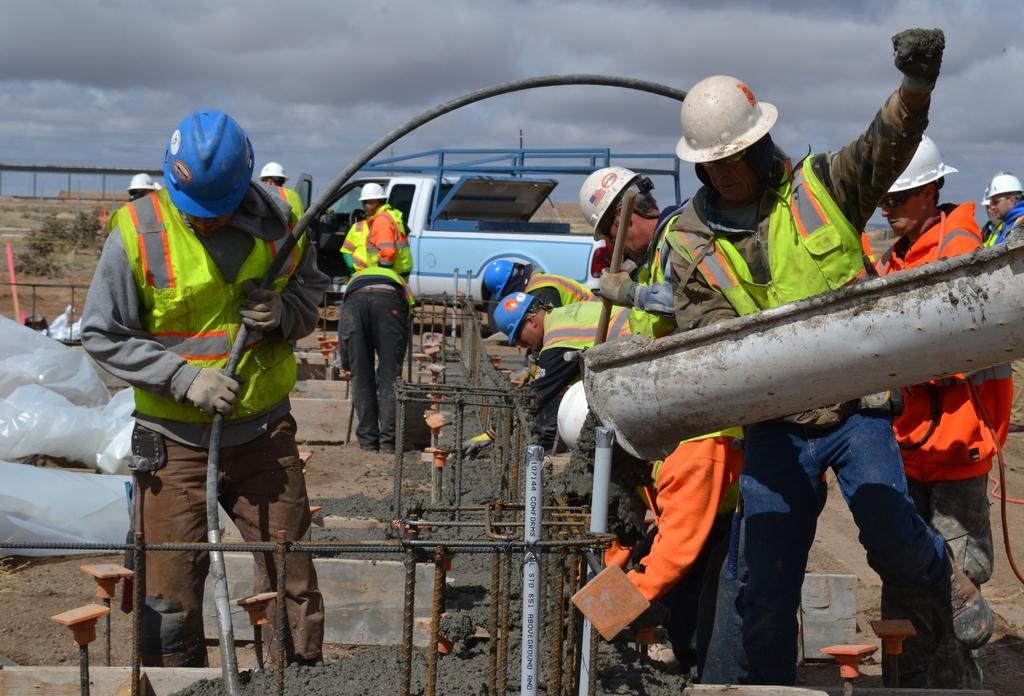How many people are in the group visible in the image? There is a group of people standing in the image, but the exact number cannot be determined from the provided facts. What type of materials can be seen in the image? Iron rods, pipes, cement, and covers are visible in the image. What type of vehicle is present in the image? There is a vehicle in the image, but its specific type cannot be determined from the provided facts. What type of natural elements can be seen in the image? Grass and plants are visible in the image. What part of the natural environment is visible in the image? The sky is visible in the image. What type of record is being played by the judge in the image? There is no record or judge present in the image. What type of railway is visible in the image? There is no railway present in the image. 